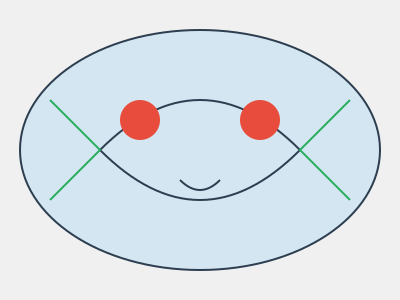As a children's book author, you're designing a unique fantasy creature for your next story. The creature has an oval-shaped body, two large eyes, a curved mouth, and symmetrical appendages on both sides. If you want to emphasize its magical nature by incorporating the golden ratio (φ) into its design, how would you determine the ideal length of its appendages in relation to its body width? To incorporate the golden ratio into the creature's design, we'll follow these steps:

1. Understand the golden ratio: The golden ratio, denoted by φ (phi), is approximately equal to 1.618033988749895.

2. Identify the known dimension: In this case, it's the width of the creature's body.

3. Set up the golden ratio equation:
   $\frac{\text{Total width}}{\text{Body width}} = \frac{\text{Body width}}{\text{Appendage length}} = φ$

4. Let's say the body width is $w$. Then the appendage length on each side would be $x$.

5. The total width would be $w + 2x$ (body width plus two appendages).

6. Plug these into the equation:
   $\frac{w + 2x}{w} = \frac{w}{x} = φ$

7. From this, we can derive:
   $w + 2x = φw$
   $2x = φw - w$
   $2x = w(φ - 1)$
   $x = \frac{w(φ - 1)}{2}$

8. Since $φ - 1 ≈ 0.618033988749895$, we can simplify:
   $x ≈ 0.309016994374947 * w$

Therefore, to achieve the golden ratio, each appendage should be approximately 0.309 times the width of the creature's body.
Answer: Appendage length ≈ 0.309 * body width 